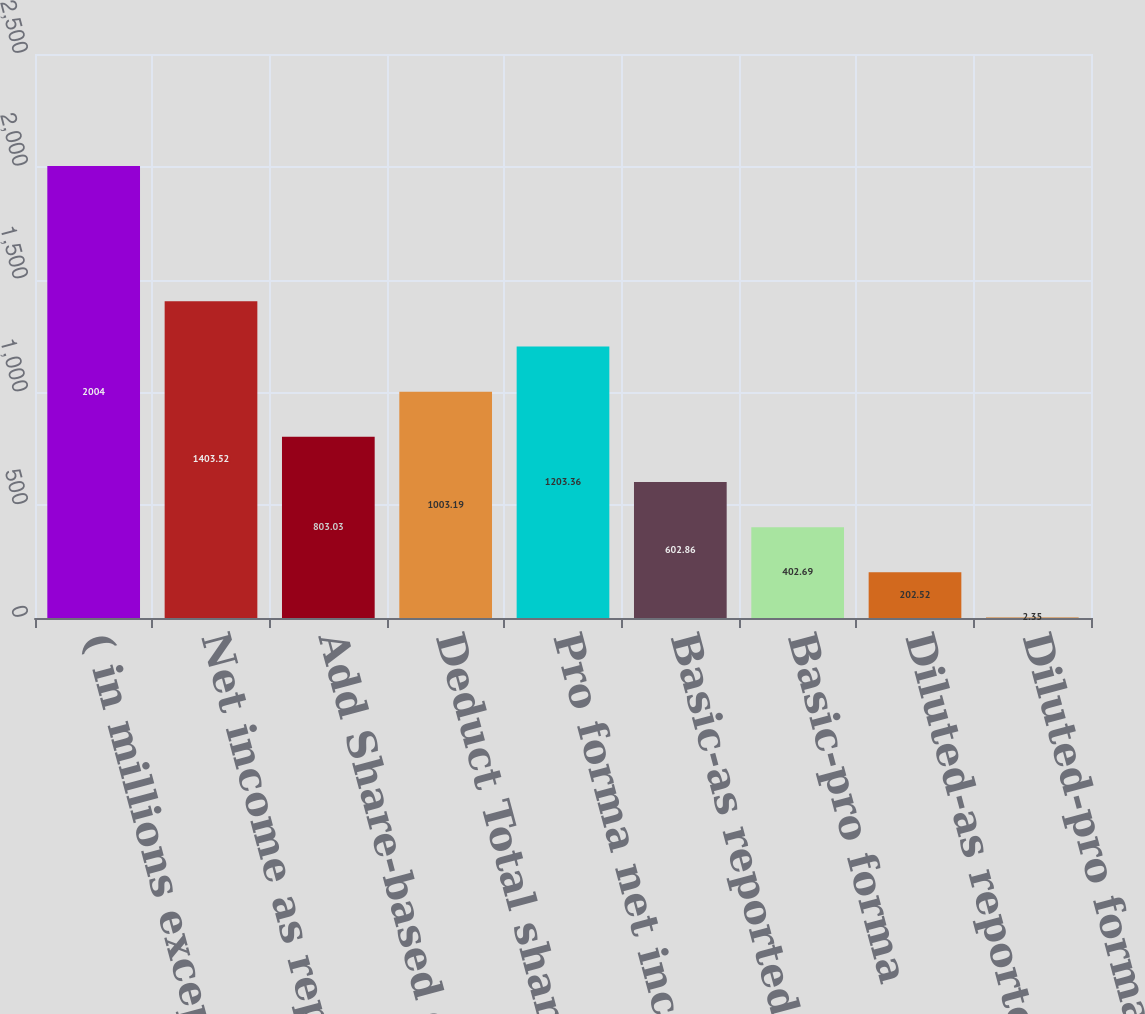Convert chart to OTSL. <chart><loc_0><loc_0><loc_500><loc_500><bar_chart><fcel>( in millions except per share<fcel>Net income as reported<fcel>Add Share-based employee<fcel>Deduct Total share-based<fcel>Pro forma net income<fcel>Basic-as reported<fcel>Basic-pro forma<fcel>Diluted-as reported<fcel>Diluted-pro forma<nl><fcel>2004<fcel>1403.52<fcel>803.03<fcel>1003.19<fcel>1203.36<fcel>602.86<fcel>402.69<fcel>202.52<fcel>2.35<nl></chart> 